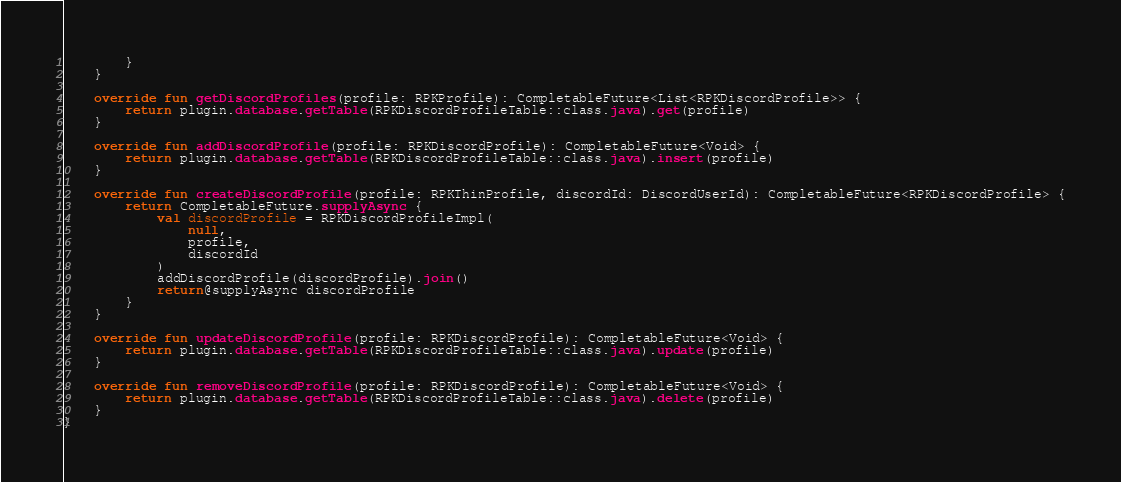Convert code to text. <code><loc_0><loc_0><loc_500><loc_500><_Kotlin_>        }
    }

    override fun getDiscordProfiles(profile: RPKProfile): CompletableFuture<List<RPKDiscordProfile>> {
        return plugin.database.getTable(RPKDiscordProfileTable::class.java).get(profile)
    }

    override fun addDiscordProfile(profile: RPKDiscordProfile): CompletableFuture<Void> {
        return plugin.database.getTable(RPKDiscordProfileTable::class.java).insert(profile)
    }

    override fun createDiscordProfile(profile: RPKThinProfile, discordId: DiscordUserId): CompletableFuture<RPKDiscordProfile> {
        return CompletableFuture.supplyAsync {
            val discordProfile = RPKDiscordProfileImpl(
                null,
                profile,
                discordId
            )
            addDiscordProfile(discordProfile).join()
            return@supplyAsync discordProfile
        }
    }

    override fun updateDiscordProfile(profile: RPKDiscordProfile): CompletableFuture<Void> {
        return plugin.database.getTable(RPKDiscordProfileTable::class.java).update(profile)
    }

    override fun removeDiscordProfile(profile: RPKDiscordProfile): CompletableFuture<Void> {
        return plugin.database.getTable(RPKDiscordProfileTable::class.java).delete(profile)
    }
}</code> 